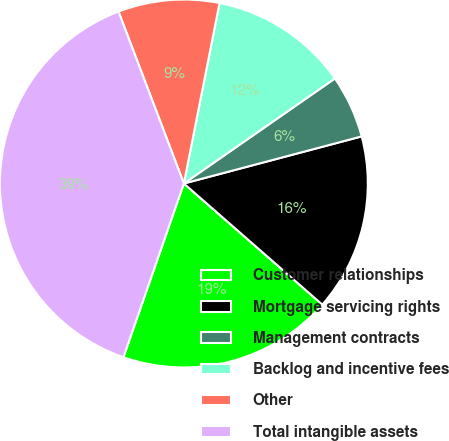Convert chart to OTSL. <chart><loc_0><loc_0><loc_500><loc_500><pie_chart><fcel>Customer relationships<fcel>Mortgage servicing rights<fcel>Management contracts<fcel>Backlog and incentive fees<fcel>Other<fcel>Total intangible assets<nl><fcel>18.89%<fcel>15.56%<fcel>5.55%<fcel>12.22%<fcel>8.89%<fcel>38.89%<nl></chart> 